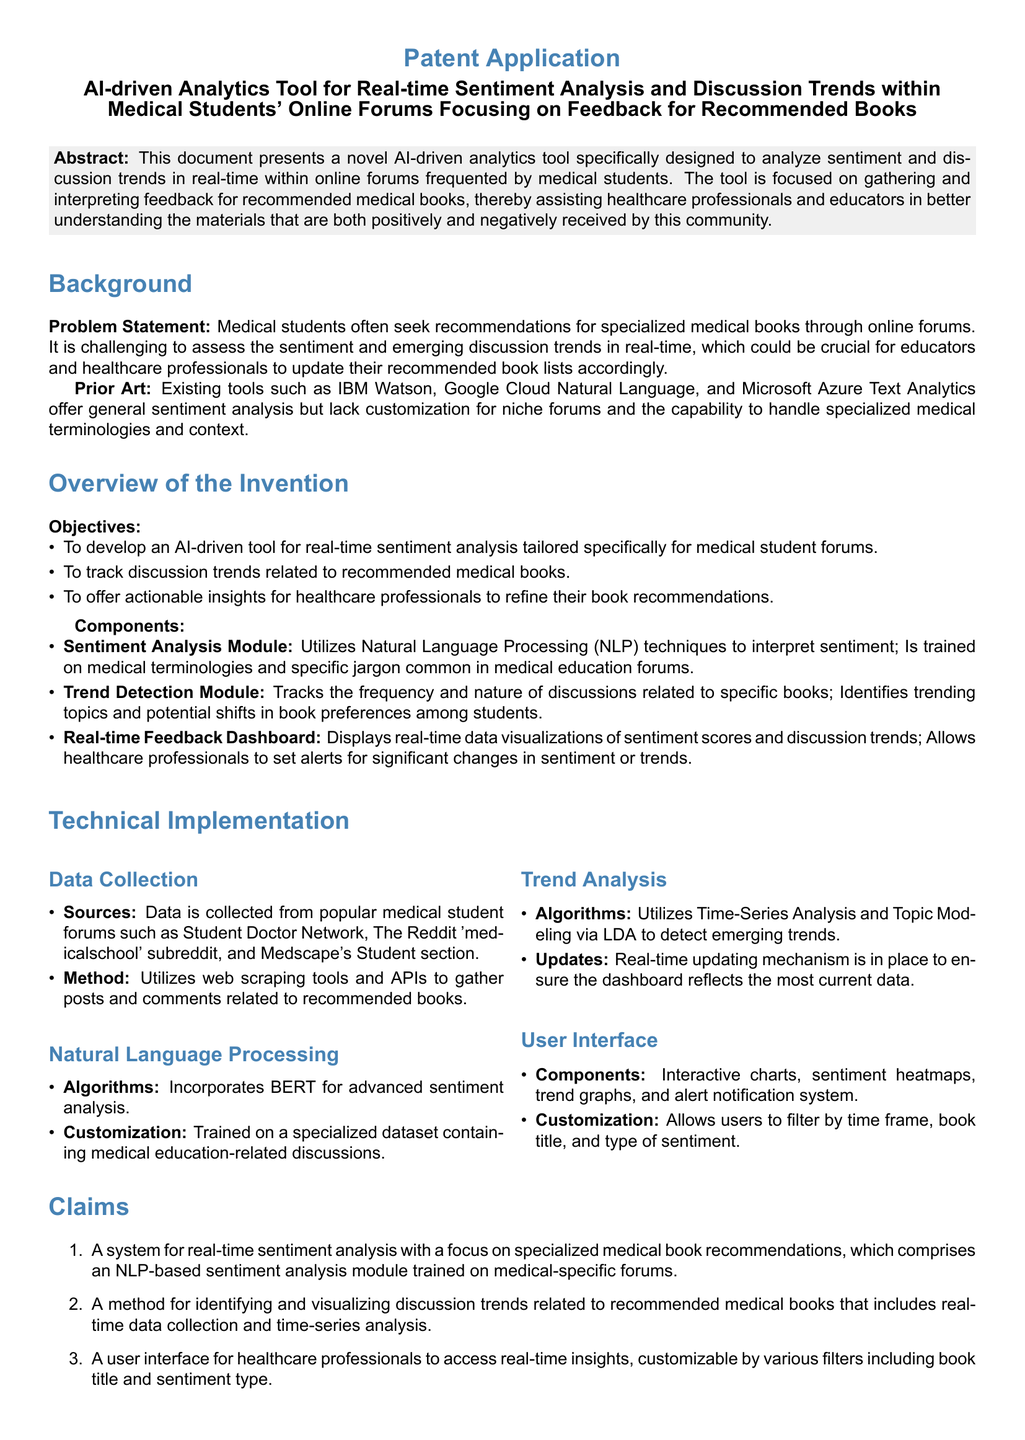What is the title of the patent application? The title is stated in the document's header as "AI-driven Analytics Tool for Real-time Sentiment Analysis and Discussion Trends within Medical Students' Online Forums Focusing on Feedback for Recommended Books."
Answer: AI-driven Analytics Tool for Real-time Sentiment Analysis and Discussion Trends within Medical Students' Online Forums Focusing on Feedback for Recommended Books What is the primary objective of the tool? The primary objective is listed in the Overview of the Invention section as developing an AI-driven tool for real-time sentiment analysis tailored specifically for medical student forums.
Answer: Real-time sentiment analysis tailored specifically for medical student forums What is one of the sources for data collection? Sources for data collection are mentioned in the Technical Implementation section, which includes popular medical student forums; one example is the "Student Doctor Network."
Answer: Student Doctor Network Which module utilizes Natural Language Processing techniques? The document explicitly mentions a "Sentiment Analysis Module" that utilizes NLP techniques to interpret sentiment.
Answer: Sentiment Analysis Module What algorithm is used for sentiment analysis? The specific algorithm mentioned in the Natural Language Processing section for sentiment analysis is BERT.
Answer: BERT How many claims are listed in the patent application? The number of claims is found in the Claims section, which lists three claims regarding the system and method described.
Answer: Three What type of visualizations does the Real-time Feedback Dashboard provide? The User Interface section includes components of the dashboard, which shows that it provides interactive charts, sentiment heatmaps, and trend graphs.
Answer: Interactive charts, sentiment heatmaps, and trend graphs Which analysis method is used to detect emerging trends? The document states that "Topic Modeling via LDA" is utilized for detecting emerging trends.
Answer: Topic Modeling via LDA 